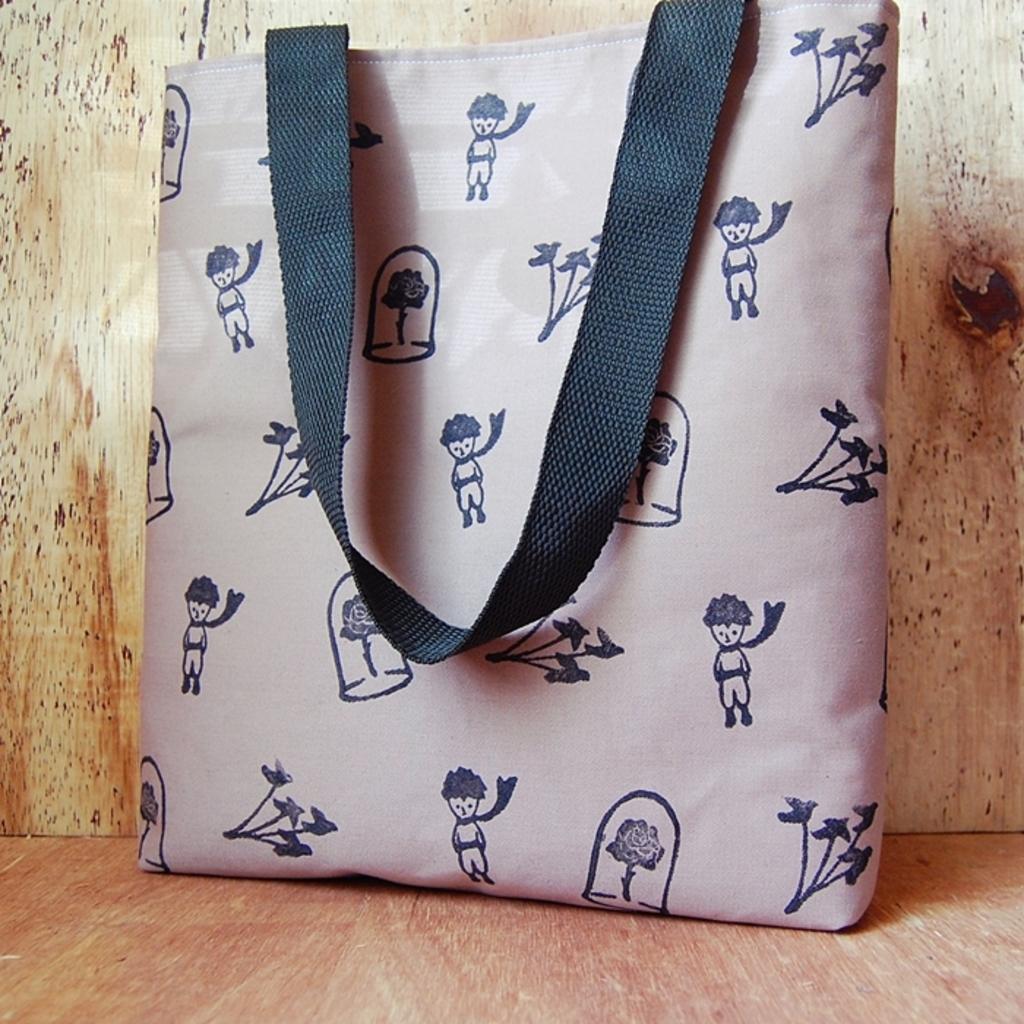Can you describe this image briefly? There is a bag in the picture, placed on the floor. In the background there is a wall. 